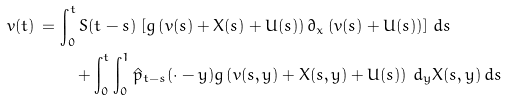<formula> <loc_0><loc_0><loc_500><loc_500>v ( t ) \, = \, & \int _ { 0 } ^ { t } S ( t - s ) \, \left [ g \left ( v ( s ) + X ( s ) + U ( s ) \right ) \partial _ { x } \left ( v ( s ) + U ( s ) \right ) \right ] \, d s \\ & \quad + \int _ { 0 } ^ { t } \int _ { 0 } ^ { 1 } \hat { p } _ { t - s } ( \cdot - y ) g \left ( v ( s , y ) + X ( s , y ) + U ( s ) \right ) \, d _ { y } X ( s , y ) \, d s</formula> 